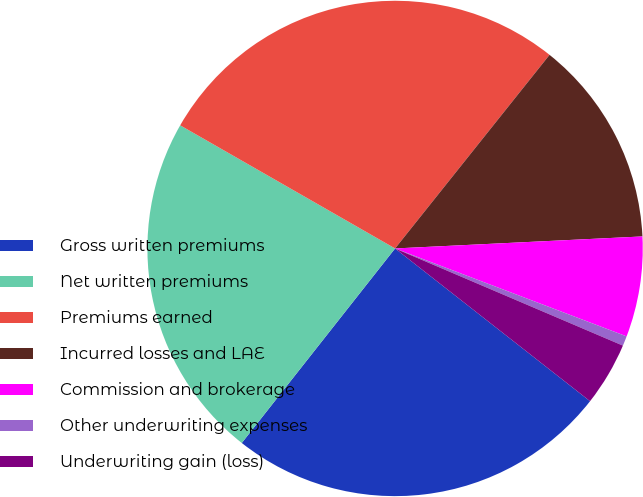Convert chart to OTSL. <chart><loc_0><loc_0><loc_500><loc_500><pie_chart><fcel>Gross written premiums<fcel>Net written premiums<fcel>Premiums earned<fcel>Incurred losses and LAE<fcel>Commission and brokerage<fcel>Other underwriting expenses<fcel>Underwriting gain (loss)<nl><fcel>25.05%<fcel>22.66%<fcel>27.44%<fcel>13.51%<fcel>6.55%<fcel>0.64%<fcel>4.16%<nl></chart> 